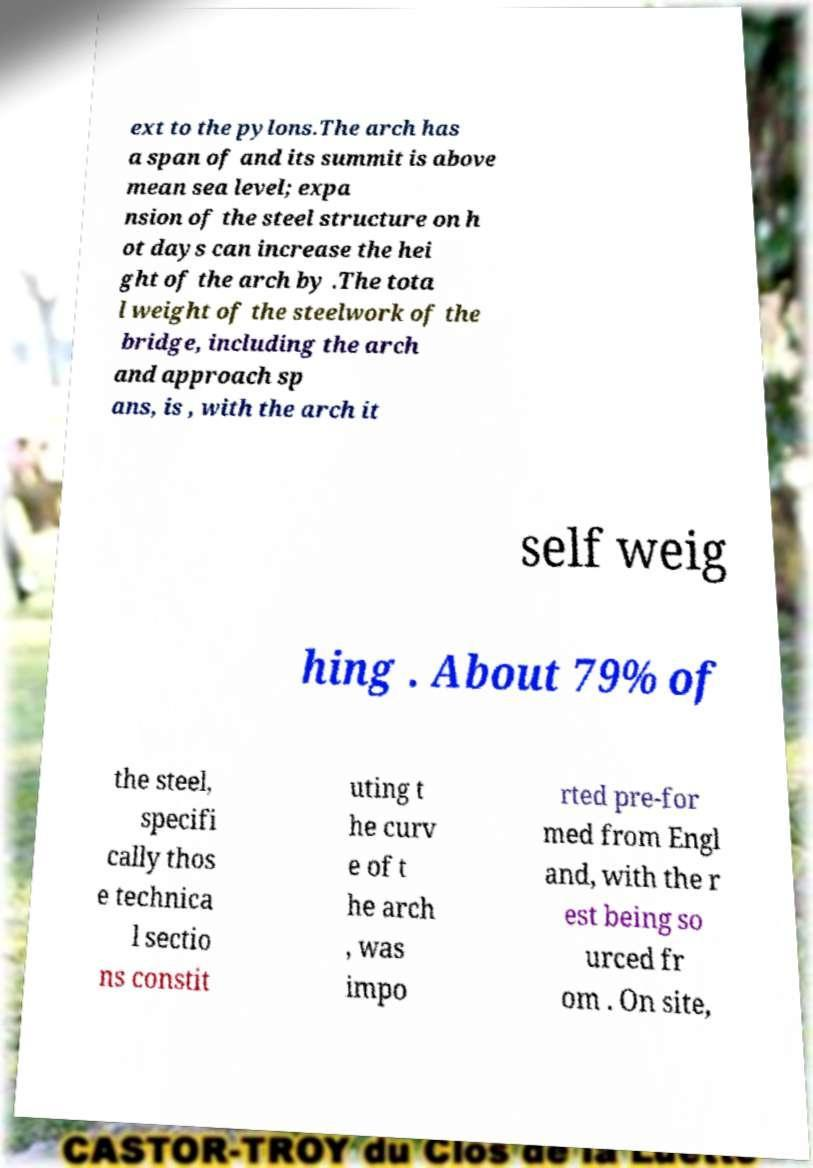Can you accurately transcribe the text from the provided image for me? ext to the pylons.The arch has a span of and its summit is above mean sea level; expa nsion of the steel structure on h ot days can increase the hei ght of the arch by .The tota l weight of the steelwork of the bridge, including the arch and approach sp ans, is , with the arch it self weig hing . About 79% of the steel, specifi cally thos e technica l sectio ns constit uting t he curv e of t he arch , was impo rted pre-for med from Engl and, with the r est being so urced fr om . On site, 